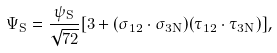<formula> <loc_0><loc_0><loc_500><loc_500>\Psi _ { S } = \frac { \psi _ { S } } { \sqrt { 7 2 } } [ 3 + ( \vec { \sigma } _ { 1 2 } \cdot \vec { \sigma } _ { 3 N } ) ( \vec { \tau } _ { 1 2 } \cdot \vec { \tau } _ { 3 N } ) ] ,</formula> 